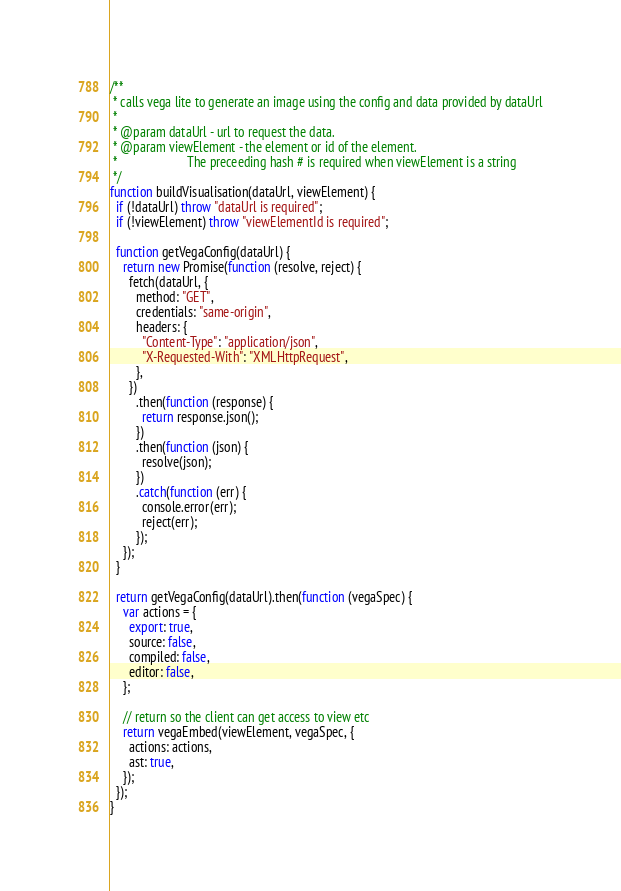<code> <loc_0><loc_0><loc_500><loc_500><_JavaScript_>/**
 * calls vega lite to generate an image using the config and data provided by dataUrl
 *
 * @param dataUrl - url to request the data.
 * @param viewElement - the element or id of the element.
 *                      The preceeding hash # is required when viewElement is a string
 */
function buildVisualisation(dataUrl, viewElement) {
  if (!dataUrl) throw "dataUrl is required";
  if (!viewElement) throw "viewElementId is required";

  function getVegaConfig(dataUrl) {
    return new Promise(function (resolve, reject) {
      fetch(dataUrl, {
        method: "GET",
        credentials: "same-origin",
        headers: {
          "Content-Type": "application/json",
          "X-Requested-With": "XMLHttpRequest",
        },
      })
        .then(function (response) {
          return response.json();
        })
        .then(function (json) {
          resolve(json);
        })
        .catch(function (err) {
          console.error(err);
          reject(err);
        });
    });
  }

  return getVegaConfig(dataUrl).then(function (vegaSpec) {
    var actions = {
      export: true,
      source: false,
      compiled: false,
      editor: false,
    };

    // return so the client can get access to view etc
    return vegaEmbed(viewElement, vegaSpec, {
      actions: actions,
      ast: true,
    });
  });
}
</code> 